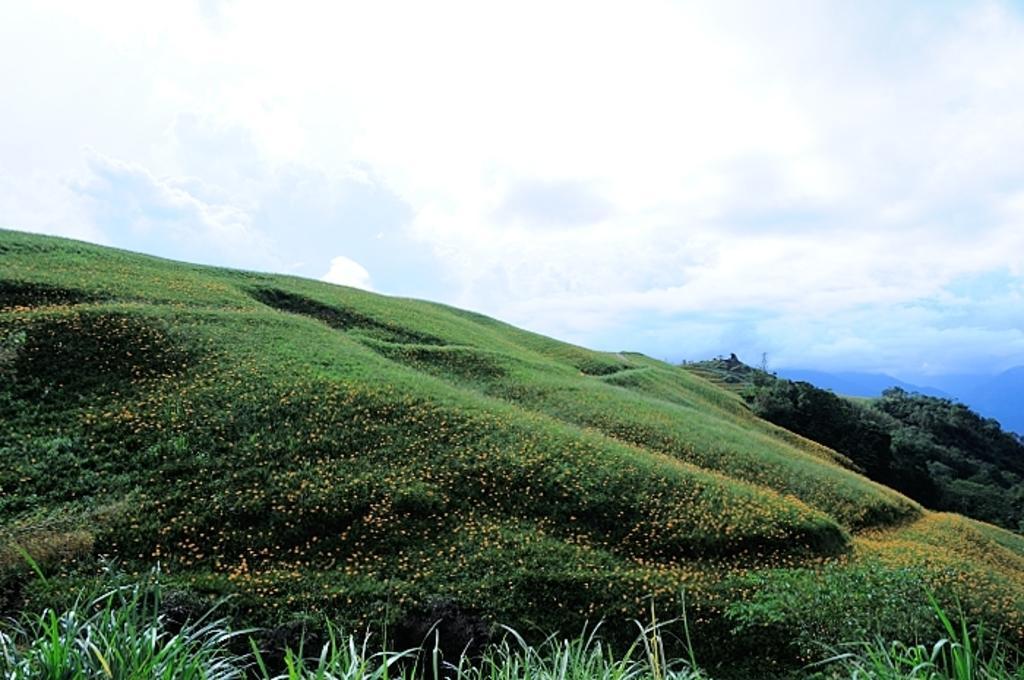In one or two sentences, can you explain what this image depicts? In this image we can see grass and plants with flowers on the ground. In the background there are clouds and on the right side we can see trees and mountains. 